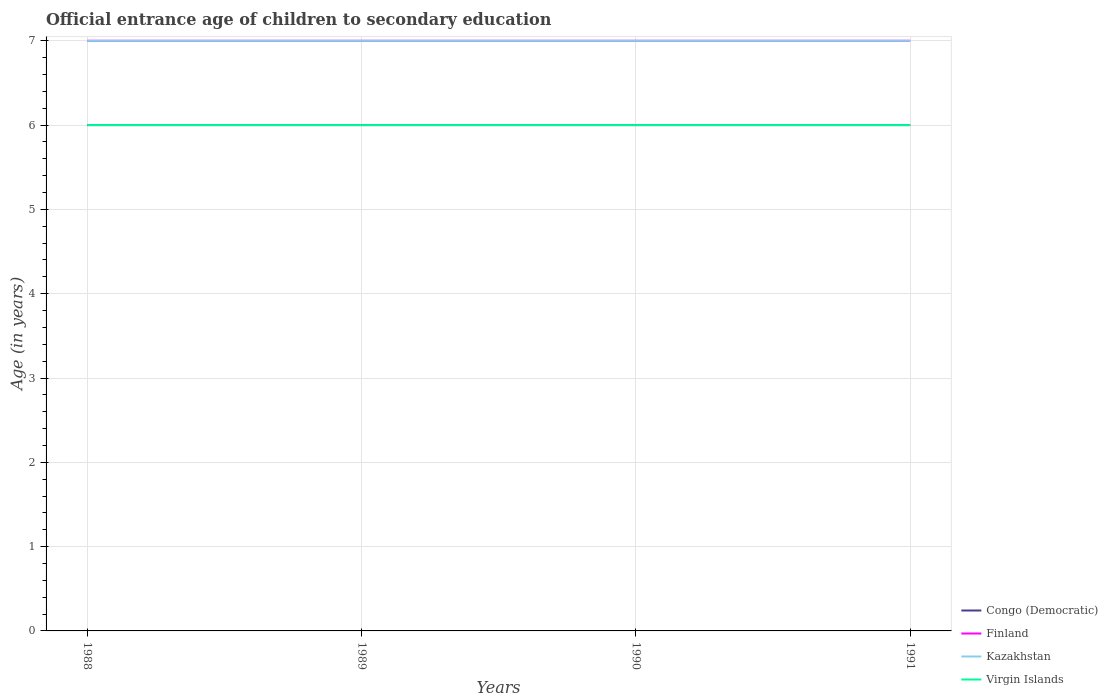Does the line corresponding to Finland intersect with the line corresponding to Kazakhstan?
Ensure brevity in your answer.  Yes. Is the number of lines equal to the number of legend labels?
Ensure brevity in your answer.  Yes. In which year was the secondary school starting age of children in Finland maximum?
Ensure brevity in your answer.  1988. What is the total secondary school starting age of children in Congo (Democratic) in the graph?
Keep it short and to the point. 0. What is the difference between the highest and the second highest secondary school starting age of children in Finland?
Make the answer very short. 0. What is the difference between the highest and the lowest secondary school starting age of children in Kazakhstan?
Your answer should be compact. 0. How many lines are there?
Your response must be concise. 4. What is the difference between two consecutive major ticks on the Y-axis?
Give a very brief answer. 1. Are the values on the major ticks of Y-axis written in scientific E-notation?
Provide a short and direct response. No. Where does the legend appear in the graph?
Make the answer very short. Bottom right. How many legend labels are there?
Provide a succinct answer. 4. What is the title of the graph?
Your answer should be compact. Official entrance age of children to secondary education. Does "Central Europe" appear as one of the legend labels in the graph?
Your response must be concise. No. What is the label or title of the X-axis?
Provide a short and direct response. Years. What is the label or title of the Y-axis?
Make the answer very short. Age (in years). What is the Age (in years) of Congo (Democratic) in 1988?
Keep it short and to the point. 6. What is the Age (in years) in Virgin Islands in 1988?
Make the answer very short. 6. What is the Age (in years) of Finland in 1989?
Give a very brief answer. 7. What is the Age (in years) of Virgin Islands in 1989?
Your answer should be compact. 6. What is the Age (in years) of Virgin Islands in 1990?
Offer a terse response. 6. What is the Age (in years) in Congo (Democratic) in 1991?
Offer a very short reply. 6. What is the Age (in years) of Finland in 1991?
Your answer should be compact. 7. What is the Age (in years) of Virgin Islands in 1991?
Your response must be concise. 6. Across all years, what is the maximum Age (in years) in Finland?
Offer a terse response. 7. Across all years, what is the maximum Age (in years) in Kazakhstan?
Your response must be concise. 7. Across all years, what is the minimum Age (in years) of Congo (Democratic)?
Offer a very short reply. 6. Across all years, what is the minimum Age (in years) of Finland?
Provide a short and direct response. 7. Across all years, what is the minimum Age (in years) of Virgin Islands?
Your response must be concise. 6. What is the total Age (in years) in Congo (Democratic) in the graph?
Provide a short and direct response. 24. What is the total Age (in years) of Kazakhstan in the graph?
Offer a terse response. 28. What is the difference between the Age (in years) in Finland in 1988 and that in 1989?
Offer a very short reply. 0. What is the difference between the Age (in years) of Kazakhstan in 1988 and that in 1989?
Your response must be concise. 0. What is the difference between the Age (in years) of Virgin Islands in 1988 and that in 1989?
Provide a short and direct response. 0. What is the difference between the Age (in years) in Congo (Democratic) in 1988 and that in 1990?
Keep it short and to the point. 0. What is the difference between the Age (in years) of Finland in 1988 and that in 1990?
Provide a succinct answer. 0. What is the difference between the Age (in years) in Virgin Islands in 1988 and that in 1990?
Your answer should be compact. 0. What is the difference between the Age (in years) in Finland in 1988 and that in 1991?
Offer a very short reply. 0. What is the difference between the Age (in years) in Kazakhstan in 1988 and that in 1991?
Provide a succinct answer. 0. What is the difference between the Age (in years) in Virgin Islands in 1988 and that in 1991?
Make the answer very short. 0. What is the difference between the Age (in years) in Finland in 1989 and that in 1990?
Provide a short and direct response. 0. What is the difference between the Age (in years) of Kazakhstan in 1989 and that in 1990?
Ensure brevity in your answer.  0. What is the difference between the Age (in years) in Virgin Islands in 1989 and that in 1990?
Offer a very short reply. 0. What is the difference between the Age (in years) in Virgin Islands in 1989 and that in 1991?
Offer a terse response. 0. What is the difference between the Age (in years) in Congo (Democratic) in 1990 and that in 1991?
Your response must be concise. 0. What is the difference between the Age (in years) of Kazakhstan in 1990 and that in 1991?
Offer a terse response. 0. What is the difference between the Age (in years) of Virgin Islands in 1990 and that in 1991?
Ensure brevity in your answer.  0. What is the difference between the Age (in years) of Congo (Democratic) in 1988 and the Age (in years) of Finland in 1989?
Your answer should be compact. -1. What is the difference between the Age (in years) in Congo (Democratic) in 1988 and the Age (in years) in Kazakhstan in 1989?
Offer a terse response. -1. What is the difference between the Age (in years) in Finland in 1988 and the Age (in years) in Kazakhstan in 1989?
Make the answer very short. 0. What is the difference between the Age (in years) in Finland in 1988 and the Age (in years) in Virgin Islands in 1989?
Offer a very short reply. 1. What is the difference between the Age (in years) of Kazakhstan in 1988 and the Age (in years) of Virgin Islands in 1989?
Offer a terse response. 1. What is the difference between the Age (in years) in Congo (Democratic) in 1988 and the Age (in years) in Kazakhstan in 1990?
Offer a terse response. -1. What is the difference between the Age (in years) of Congo (Democratic) in 1988 and the Age (in years) of Finland in 1991?
Provide a succinct answer. -1. What is the difference between the Age (in years) of Congo (Democratic) in 1988 and the Age (in years) of Kazakhstan in 1991?
Ensure brevity in your answer.  -1. What is the difference between the Age (in years) of Congo (Democratic) in 1988 and the Age (in years) of Virgin Islands in 1991?
Make the answer very short. 0. What is the difference between the Age (in years) in Finland in 1988 and the Age (in years) in Kazakhstan in 1991?
Offer a very short reply. 0. What is the difference between the Age (in years) of Finland in 1989 and the Age (in years) of Kazakhstan in 1990?
Give a very brief answer. 0. What is the difference between the Age (in years) of Finland in 1989 and the Age (in years) of Virgin Islands in 1990?
Your answer should be compact. 1. What is the difference between the Age (in years) in Congo (Democratic) in 1989 and the Age (in years) in Kazakhstan in 1991?
Your answer should be very brief. -1. What is the difference between the Age (in years) of Finland in 1989 and the Age (in years) of Kazakhstan in 1991?
Offer a terse response. 0. What is the difference between the Age (in years) of Kazakhstan in 1989 and the Age (in years) of Virgin Islands in 1991?
Provide a succinct answer. 1. What is the difference between the Age (in years) in Congo (Democratic) in 1990 and the Age (in years) in Finland in 1991?
Provide a short and direct response. -1. What is the difference between the Age (in years) of Congo (Democratic) in 1990 and the Age (in years) of Kazakhstan in 1991?
Offer a terse response. -1. What is the difference between the Age (in years) in Congo (Democratic) in 1990 and the Age (in years) in Virgin Islands in 1991?
Your response must be concise. 0. What is the difference between the Age (in years) of Finland in 1990 and the Age (in years) of Kazakhstan in 1991?
Your answer should be compact. 0. What is the difference between the Age (in years) of Finland in 1990 and the Age (in years) of Virgin Islands in 1991?
Ensure brevity in your answer.  1. What is the difference between the Age (in years) in Kazakhstan in 1990 and the Age (in years) in Virgin Islands in 1991?
Your answer should be compact. 1. What is the average Age (in years) in Finland per year?
Offer a terse response. 7. What is the average Age (in years) of Virgin Islands per year?
Your answer should be compact. 6. In the year 1988, what is the difference between the Age (in years) of Congo (Democratic) and Age (in years) of Kazakhstan?
Offer a terse response. -1. In the year 1988, what is the difference between the Age (in years) in Congo (Democratic) and Age (in years) in Virgin Islands?
Your response must be concise. 0. In the year 1988, what is the difference between the Age (in years) in Finland and Age (in years) in Virgin Islands?
Provide a succinct answer. 1. In the year 1990, what is the difference between the Age (in years) of Kazakhstan and Age (in years) of Virgin Islands?
Provide a short and direct response. 1. In the year 1991, what is the difference between the Age (in years) in Congo (Democratic) and Age (in years) in Finland?
Your response must be concise. -1. In the year 1991, what is the difference between the Age (in years) in Finland and Age (in years) in Kazakhstan?
Provide a succinct answer. 0. In the year 1991, what is the difference between the Age (in years) in Finland and Age (in years) in Virgin Islands?
Give a very brief answer. 1. In the year 1991, what is the difference between the Age (in years) of Kazakhstan and Age (in years) of Virgin Islands?
Provide a short and direct response. 1. What is the ratio of the Age (in years) in Congo (Democratic) in 1988 to that in 1989?
Provide a short and direct response. 1. What is the ratio of the Age (in years) of Congo (Democratic) in 1988 to that in 1990?
Your answer should be very brief. 1. What is the ratio of the Age (in years) of Finland in 1988 to that in 1990?
Keep it short and to the point. 1. What is the ratio of the Age (in years) of Finland in 1988 to that in 1991?
Ensure brevity in your answer.  1. What is the ratio of the Age (in years) of Kazakhstan in 1988 to that in 1991?
Make the answer very short. 1. What is the ratio of the Age (in years) in Virgin Islands in 1988 to that in 1991?
Ensure brevity in your answer.  1. What is the ratio of the Age (in years) of Kazakhstan in 1989 to that in 1990?
Keep it short and to the point. 1. What is the ratio of the Age (in years) in Finland in 1989 to that in 1991?
Provide a succinct answer. 1. What is the ratio of the Age (in years) in Kazakhstan in 1989 to that in 1991?
Make the answer very short. 1. What is the ratio of the Age (in years) of Virgin Islands in 1989 to that in 1991?
Make the answer very short. 1. What is the ratio of the Age (in years) in Congo (Democratic) in 1990 to that in 1991?
Provide a short and direct response. 1. What is the ratio of the Age (in years) of Finland in 1990 to that in 1991?
Your response must be concise. 1. What is the ratio of the Age (in years) of Virgin Islands in 1990 to that in 1991?
Your response must be concise. 1. What is the difference between the highest and the second highest Age (in years) in Kazakhstan?
Give a very brief answer. 0. What is the difference between the highest and the second highest Age (in years) of Virgin Islands?
Your answer should be very brief. 0. What is the difference between the highest and the lowest Age (in years) in Finland?
Offer a terse response. 0. What is the difference between the highest and the lowest Age (in years) in Kazakhstan?
Make the answer very short. 0. What is the difference between the highest and the lowest Age (in years) of Virgin Islands?
Offer a very short reply. 0. 